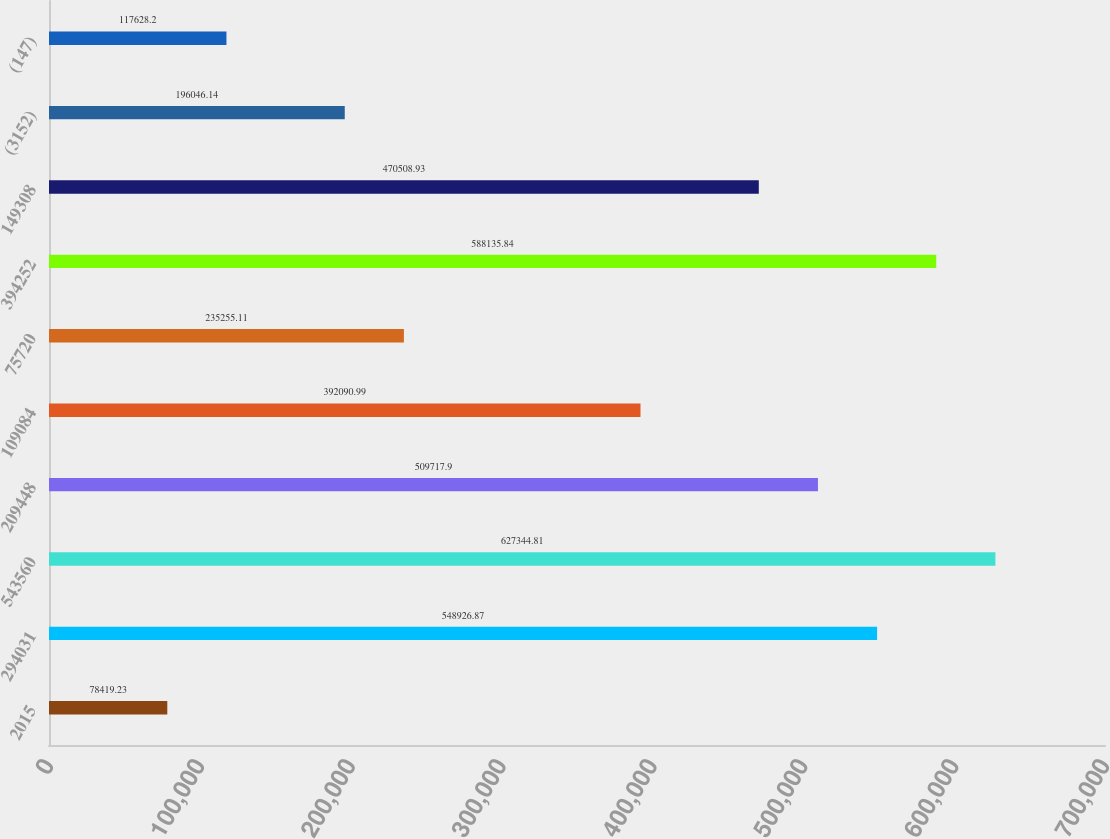Convert chart. <chart><loc_0><loc_0><loc_500><loc_500><bar_chart><fcel>2015<fcel>294031<fcel>543560<fcel>209448<fcel>109084<fcel>75720<fcel>394252<fcel>149308<fcel>(3152)<fcel>(147)<nl><fcel>78419.2<fcel>548927<fcel>627345<fcel>509718<fcel>392091<fcel>235255<fcel>588136<fcel>470509<fcel>196046<fcel>117628<nl></chart> 